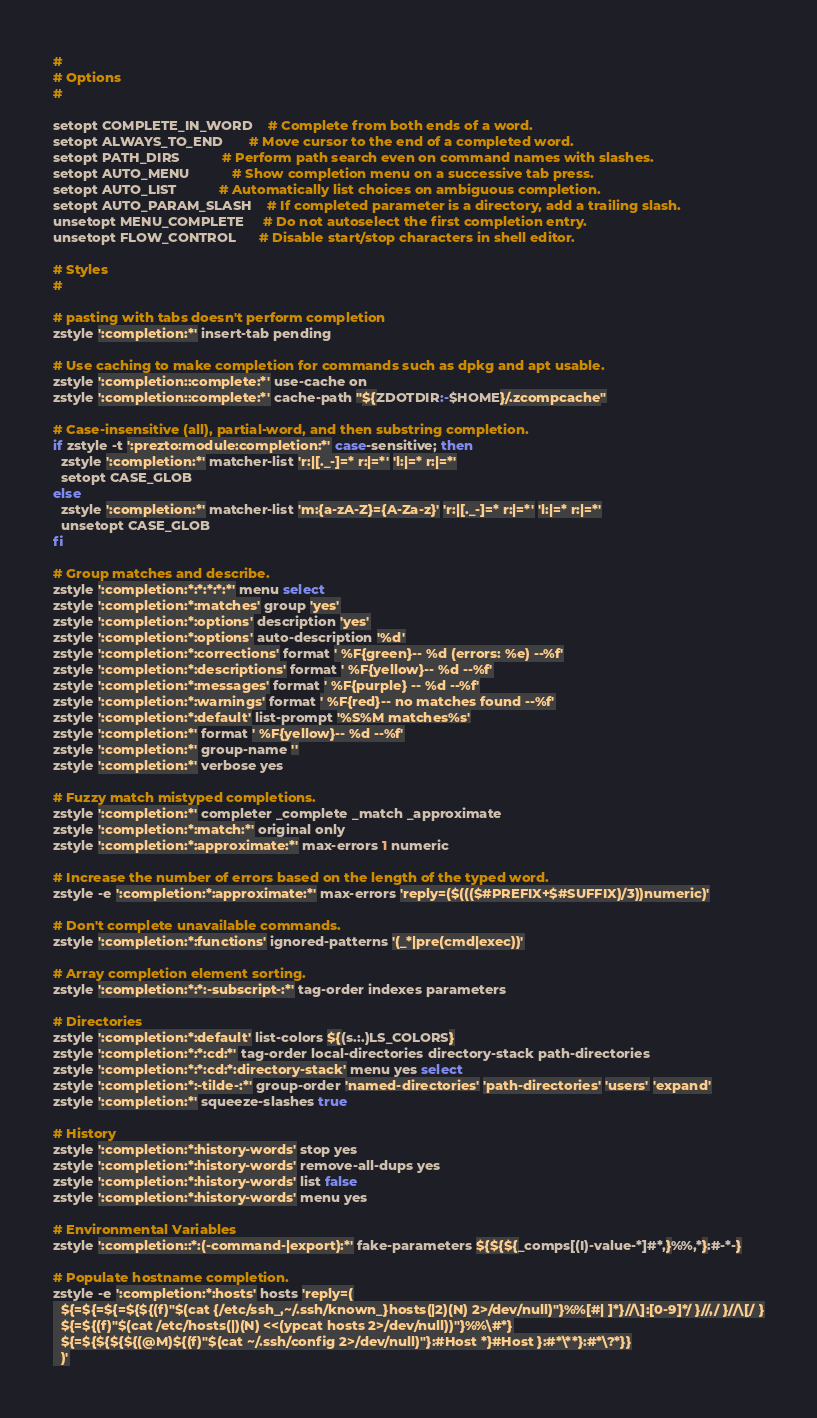<code> <loc_0><loc_0><loc_500><loc_500><_Bash_>#
# Options
#

setopt COMPLETE_IN_WORD    # Complete from both ends of a word.
setopt ALWAYS_TO_END       # Move cursor to the end of a completed word.
setopt PATH_DIRS           # Perform path search even on command names with slashes.
setopt AUTO_MENU           # Show completion menu on a successive tab press.
setopt AUTO_LIST           # Automatically list choices on ambiguous completion.
setopt AUTO_PARAM_SLASH    # If completed parameter is a directory, add a trailing slash.
unsetopt MENU_COMPLETE     # Do not autoselect the first completion entry.
unsetopt FLOW_CONTROL      # Disable start/stop characters in shell editor.

# Styles
#

# pasting with tabs doesn't perform completion
zstyle ':completion:*' insert-tab pending

# Use caching to make completion for commands such as dpkg and apt usable.
zstyle ':completion::complete:*' use-cache on
zstyle ':completion::complete:*' cache-path "${ZDOTDIR:-$HOME}/.zcompcache"

# Case-insensitive (all), partial-word, and then substring completion.
if zstyle -t ':prezto:module:completion:*' case-sensitive; then
  zstyle ':completion:*' matcher-list 'r:|[._-]=* r:|=*' 'l:|=* r:|=*'
  setopt CASE_GLOB
else
  zstyle ':completion:*' matcher-list 'm:{a-zA-Z}={A-Za-z}' 'r:|[._-]=* r:|=*' 'l:|=* r:|=*'
  unsetopt CASE_GLOB
fi

# Group matches and describe.
zstyle ':completion:*:*:*:*:*' menu select
zstyle ':completion:*:matches' group 'yes'
zstyle ':completion:*:options' description 'yes'
zstyle ':completion:*:options' auto-description '%d'
zstyle ':completion:*:corrections' format ' %F{green}-- %d (errors: %e) --%f'
zstyle ':completion:*:descriptions' format ' %F{yellow}-- %d --%f'
zstyle ':completion:*:messages' format ' %F{purple} -- %d --%f'
zstyle ':completion:*:warnings' format ' %F{red}-- no matches found --%f'
zstyle ':completion:*:default' list-prompt '%S%M matches%s'
zstyle ':completion:*' format ' %F{yellow}-- %d --%f'
zstyle ':completion:*' group-name ''
zstyle ':completion:*' verbose yes

# Fuzzy match mistyped completions.
zstyle ':completion:*' completer _complete _match _approximate
zstyle ':completion:*:match:*' original only
zstyle ':completion:*:approximate:*' max-errors 1 numeric

# Increase the number of errors based on the length of the typed word.
zstyle -e ':completion:*:approximate:*' max-errors 'reply=($((($#PREFIX+$#SUFFIX)/3))numeric)'

# Don't complete unavailable commands.
zstyle ':completion:*:functions' ignored-patterns '(_*|pre(cmd|exec))'

# Array completion element sorting.
zstyle ':completion:*:*:-subscript-:*' tag-order indexes parameters

# Directories
zstyle ':completion:*:default' list-colors ${(s.:.)LS_COLORS}
zstyle ':completion:*:*:cd:*' tag-order local-directories directory-stack path-directories
zstyle ':completion:*:*:cd:*:directory-stack' menu yes select
zstyle ':completion:*:-tilde-:*' group-order 'named-directories' 'path-directories' 'users' 'expand'
zstyle ':completion:*' squeeze-slashes true

# History
zstyle ':completion:*:history-words' stop yes
zstyle ':completion:*:history-words' remove-all-dups yes
zstyle ':completion:*:history-words' list false
zstyle ':completion:*:history-words' menu yes

# Environmental Variables
zstyle ':completion::*:(-command-|export):*' fake-parameters ${${${_comps[(I)-value-*]#*,}%%,*}:#-*-}

# Populate hostname completion.
zstyle -e ':completion:*:hosts' hosts 'reply=(
  ${=${=${=${${(f)"$(cat {/etc/ssh_,~/.ssh/known_}hosts(|2)(N) 2>/dev/null)"}%%[#| ]*}//\]:[0-9]*/ }//,/ }//\[/ }
  ${=${(f)"$(cat /etc/hosts(|)(N) <<(ypcat hosts 2>/dev/null))"}%%\#*}
  ${=${${${${(@M)${(f)"$(cat ~/.ssh/config 2>/dev/null)"}:#Host *}#Host }:#*\**}:#*\?*}}
  )'
</code> 